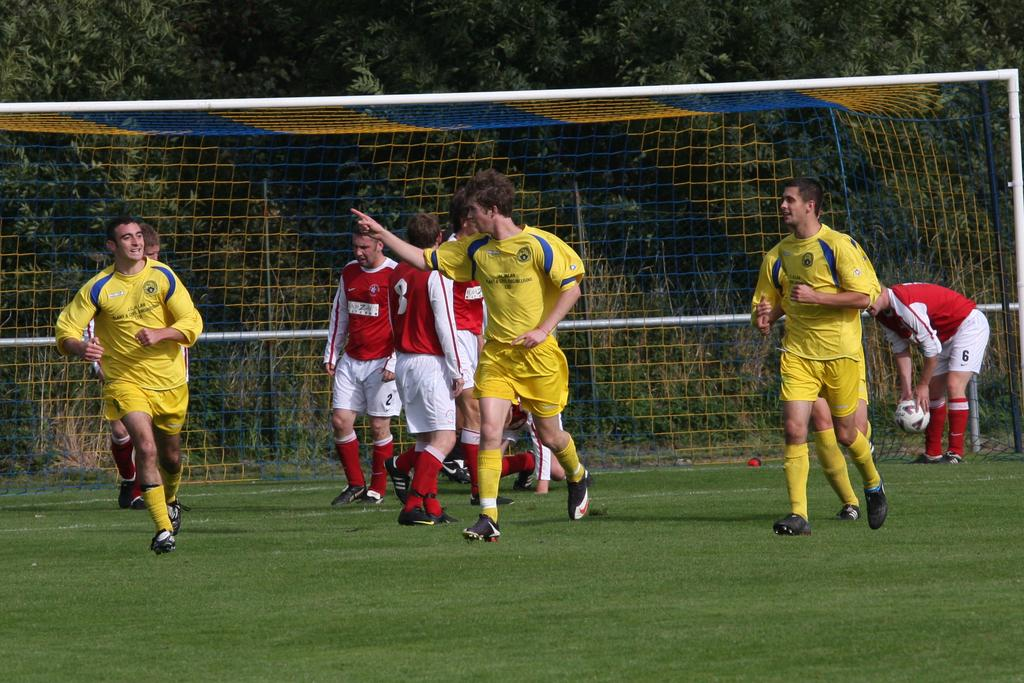What type of natural elements can be seen in the image? There are trees in the image. Are there any human subjects in the image? Yes, there are people in the image. What type of facial expression can be seen on the trees in the image? Trees do not have facial expressions, as they are inanimate objects. 